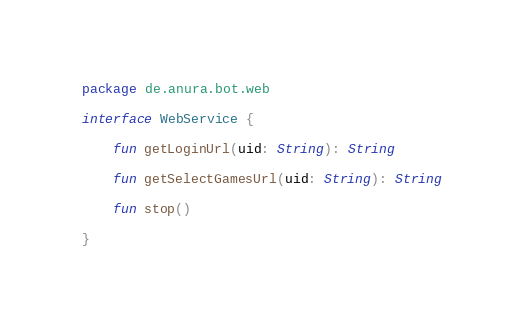<code> <loc_0><loc_0><loc_500><loc_500><_Kotlin_>package de.anura.bot.web

interface WebService {

    fun getLoginUrl(uid: String): String

    fun getSelectGamesUrl(uid: String): String

    fun stop()

}</code> 